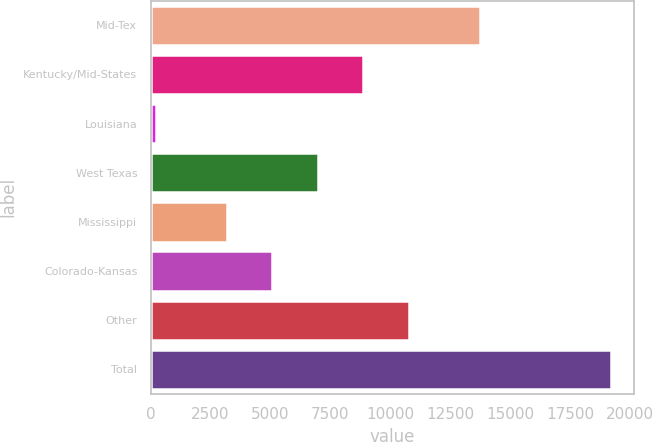<chart> <loc_0><loc_0><loc_500><loc_500><bar_chart><fcel>Mid-Tex<fcel>Kentucky/Mid-States<fcel>Louisiana<fcel>West Texas<fcel>Mississippi<fcel>Colorado-Kansas<fcel>Other<fcel>Total<nl><fcel>13761<fcel>8878.4<fcel>224<fcel>6981.6<fcel>3188<fcel>5084.8<fcel>10775.2<fcel>19192<nl></chart> 